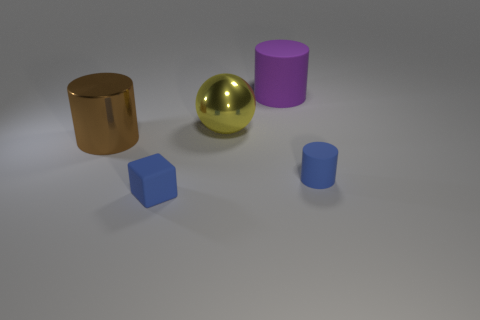Subtract all blue cylinders. How many cylinders are left? 2 Add 2 large red matte things. How many objects exist? 7 Subtract all spheres. How many objects are left? 4 Subtract all tiny things. Subtract all balls. How many objects are left? 2 Add 4 big yellow metallic balls. How many big yellow metallic balls are left? 5 Add 3 small red blocks. How many small red blocks exist? 3 Subtract 0 yellow cylinders. How many objects are left? 5 